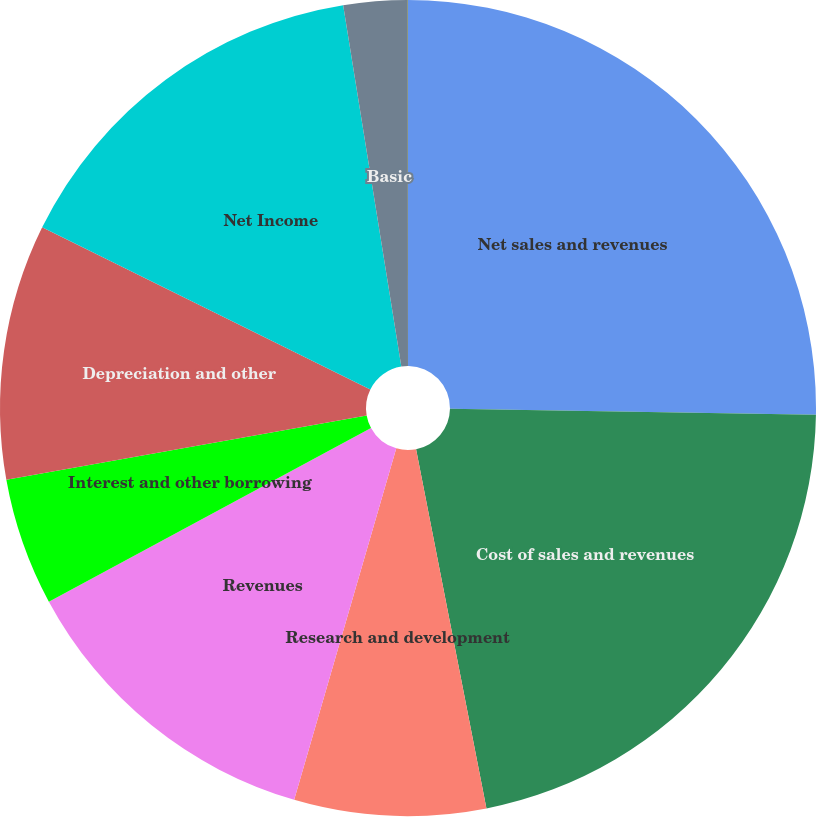Convert chart. <chart><loc_0><loc_0><loc_500><loc_500><pie_chart><fcel>Net sales and revenues<fcel>Cost of sales and revenues<fcel>Research and development<fcel>Revenues<fcel>Interest and other borrowing<fcel>Depreciation and other<fcel>Net Income<fcel>Basic<fcel>Diluted<nl><fcel>25.26%<fcel>21.66%<fcel>7.58%<fcel>12.63%<fcel>5.06%<fcel>10.11%<fcel>15.16%<fcel>2.53%<fcel>0.01%<nl></chart> 